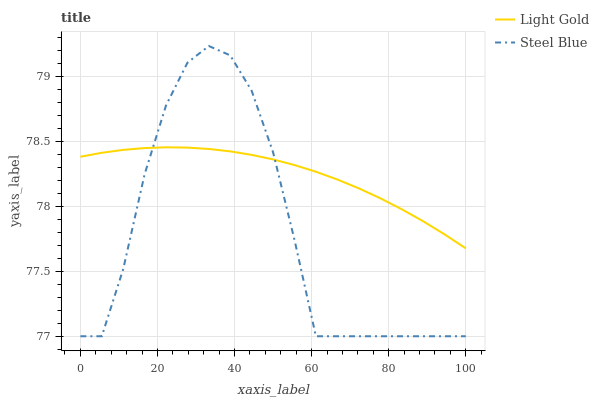Does Steel Blue have the minimum area under the curve?
Answer yes or no. Yes. Does Light Gold have the maximum area under the curve?
Answer yes or no. Yes. Does Steel Blue have the maximum area under the curve?
Answer yes or no. No. Is Light Gold the smoothest?
Answer yes or no. Yes. Is Steel Blue the roughest?
Answer yes or no. Yes. Is Steel Blue the smoothest?
Answer yes or no. No. Does Steel Blue have the highest value?
Answer yes or no. Yes. 